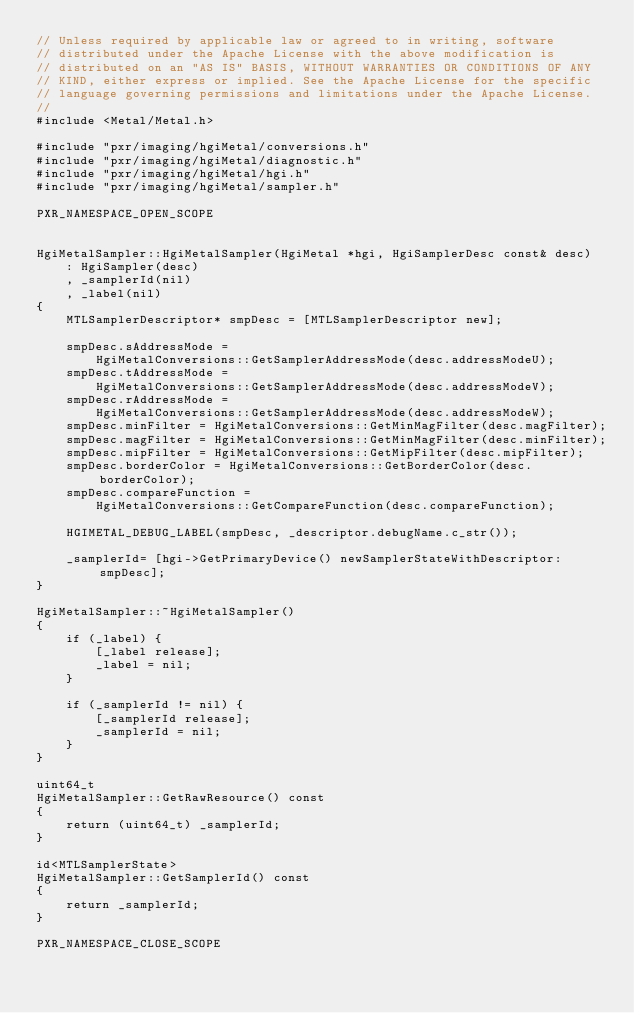Convert code to text. <code><loc_0><loc_0><loc_500><loc_500><_ObjectiveC_>// Unless required by applicable law or agreed to in writing, software
// distributed under the Apache License with the above modification is
// distributed on an "AS IS" BASIS, WITHOUT WARRANTIES OR CONDITIONS OF ANY
// KIND, either express or implied. See the Apache License for the specific
// language governing permissions and limitations under the Apache License.
//
#include <Metal/Metal.h>

#include "pxr/imaging/hgiMetal/conversions.h"
#include "pxr/imaging/hgiMetal/diagnostic.h"
#include "pxr/imaging/hgiMetal/hgi.h"
#include "pxr/imaging/hgiMetal/sampler.h"

PXR_NAMESPACE_OPEN_SCOPE


HgiMetalSampler::HgiMetalSampler(HgiMetal *hgi, HgiSamplerDesc const& desc)
    : HgiSampler(desc)
    , _samplerId(nil)
    , _label(nil)
{
    MTLSamplerDescriptor* smpDesc = [MTLSamplerDescriptor new];

    smpDesc.sAddressMode =
        HgiMetalConversions::GetSamplerAddressMode(desc.addressModeU);
    smpDesc.tAddressMode =
        HgiMetalConversions::GetSamplerAddressMode(desc.addressModeV);
    smpDesc.rAddressMode =
        HgiMetalConversions::GetSamplerAddressMode(desc.addressModeW);
    smpDesc.minFilter = HgiMetalConversions::GetMinMagFilter(desc.magFilter);
    smpDesc.magFilter = HgiMetalConversions::GetMinMagFilter(desc.minFilter);
    smpDesc.mipFilter = HgiMetalConversions::GetMipFilter(desc.mipFilter);
    smpDesc.borderColor = HgiMetalConversions::GetBorderColor(desc.borderColor);
    smpDesc.compareFunction = 
        HgiMetalConversions::GetCompareFunction(desc.compareFunction);
    
    HGIMETAL_DEBUG_LABEL(smpDesc, _descriptor.debugName.c_str());
    
    _samplerId= [hgi->GetPrimaryDevice() newSamplerStateWithDescriptor:smpDesc];
}

HgiMetalSampler::~HgiMetalSampler()
{
    if (_label) {
        [_label release];
        _label = nil;
    }

    if (_samplerId != nil) {
        [_samplerId release];
        _samplerId = nil;
    }
}

uint64_t
HgiMetalSampler::GetRawResource() const
{
    return (uint64_t) _samplerId;
}

id<MTLSamplerState>
HgiMetalSampler::GetSamplerId() const
{
    return _samplerId;
}

PXR_NAMESPACE_CLOSE_SCOPE
</code> 